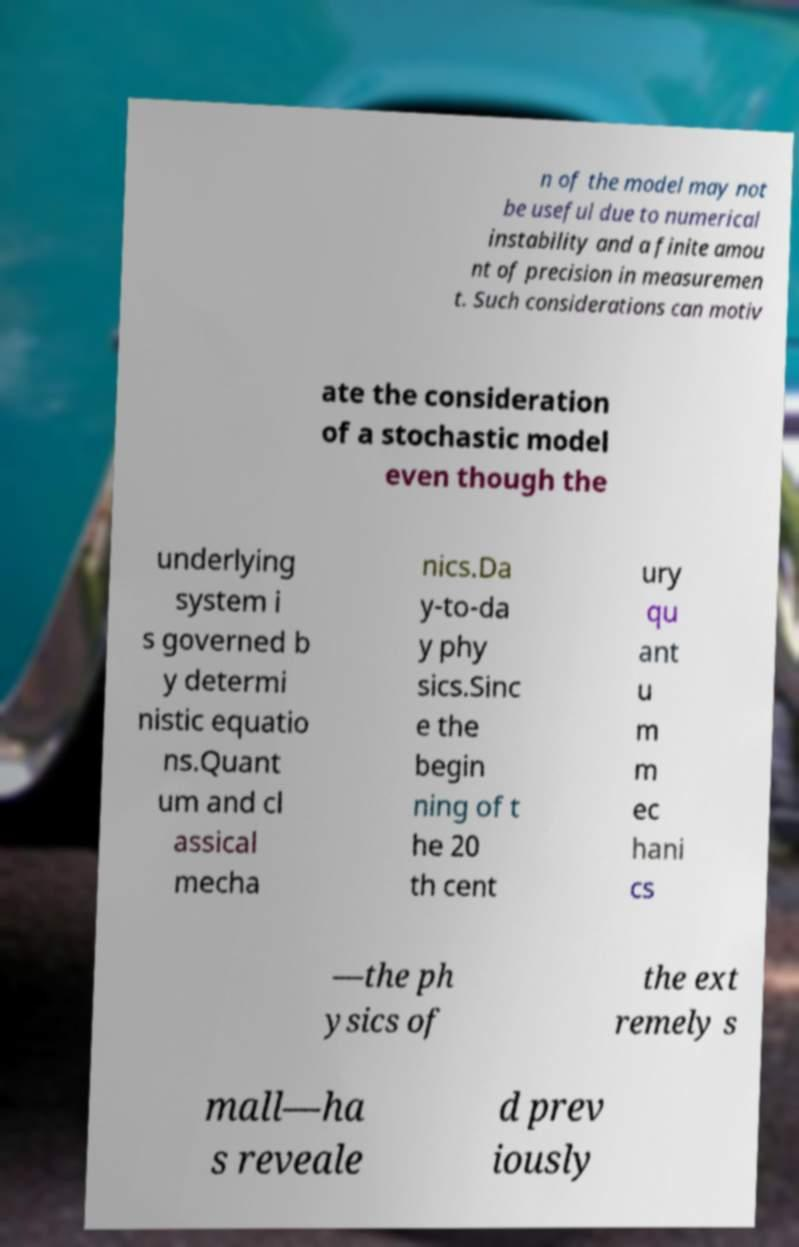Please identify and transcribe the text found in this image. n of the model may not be useful due to numerical instability and a finite amou nt of precision in measuremen t. Such considerations can motiv ate the consideration of a stochastic model even though the underlying system i s governed b y determi nistic equatio ns.Quant um and cl assical mecha nics.Da y-to-da y phy sics.Sinc e the begin ning of t he 20 th cent ury qu ant u m m ec hani cs —the ph ysics of the ext remely s mall—ha s reveale d prev iously 